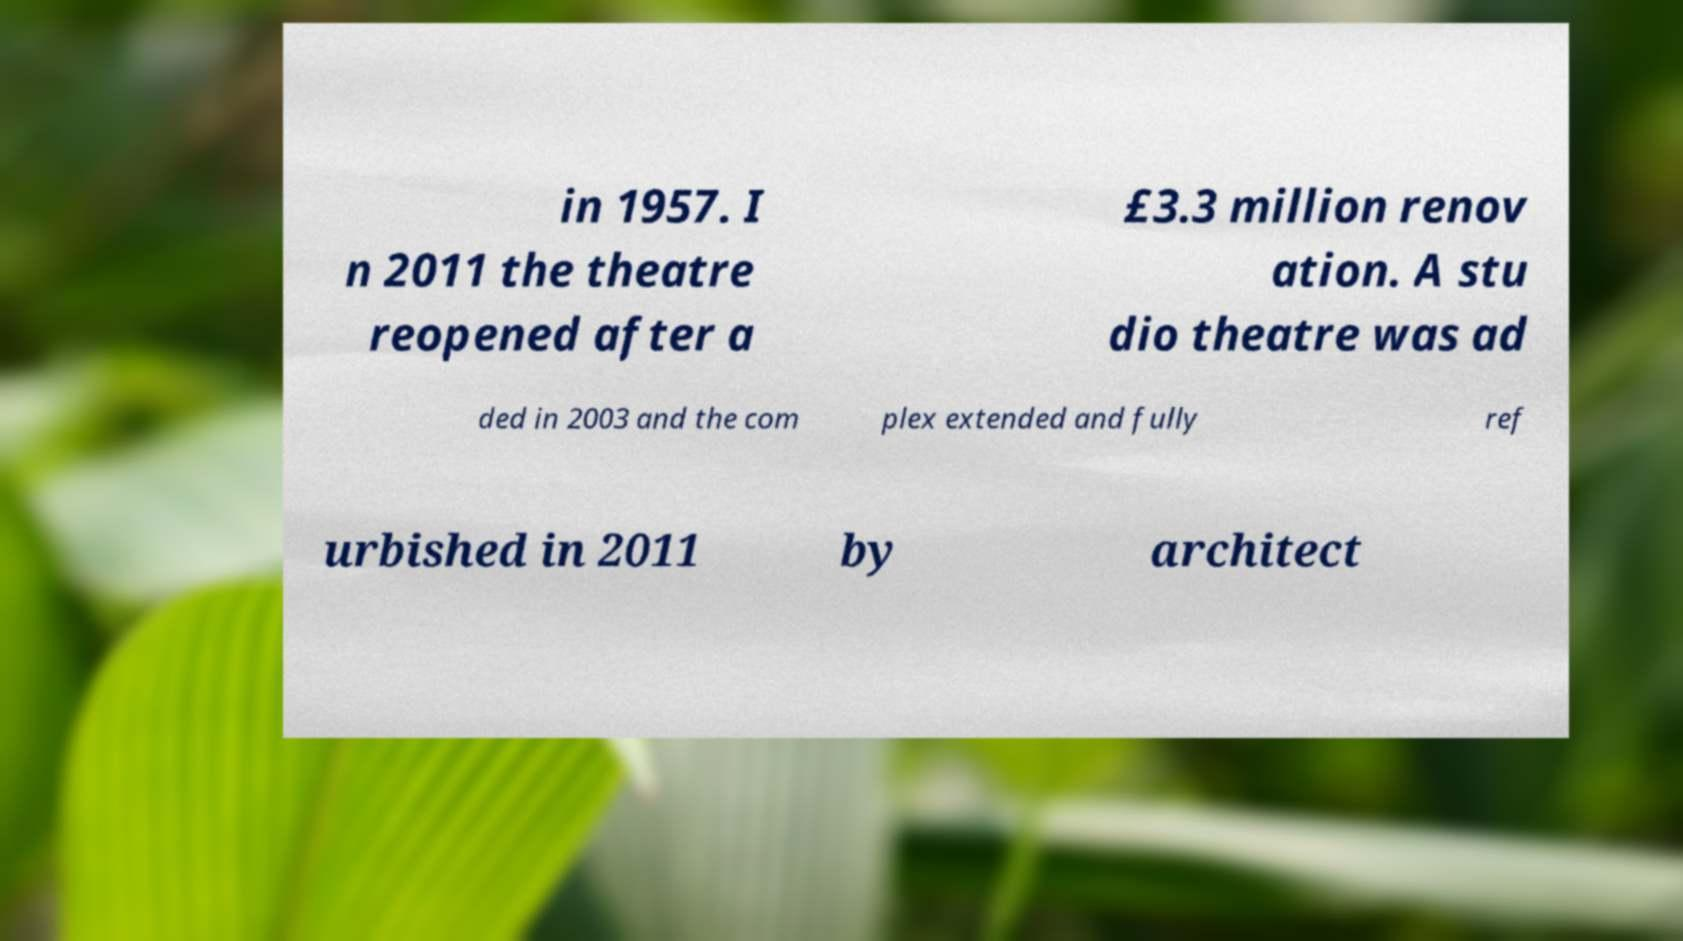There's text embedded in this image that I need extracted. Can you transcribe it verbatim? in 1957. I n 2011 the theatre reopened after a £3.3 million renov ation. A stu dio theatre was ad ded in 2003 and the com plex extended and fully ref urbished in 2011 by architect 